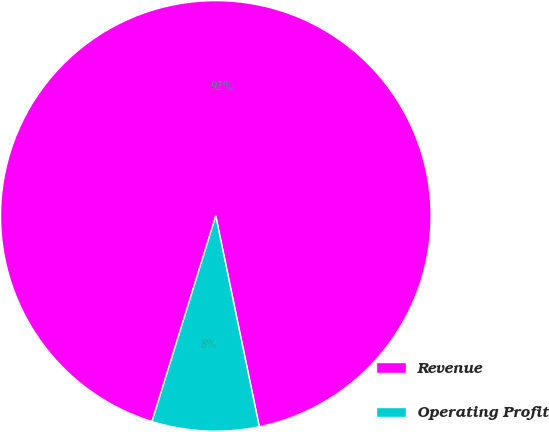Convert chart to OTSL. <chart><loc_0><loc_0><loc_500><loc_500><pie_chart><fcel>Revenue<fcel>Operating Profit<nl><fcel>91.97%<fcel>8.03%<nl></chart> 